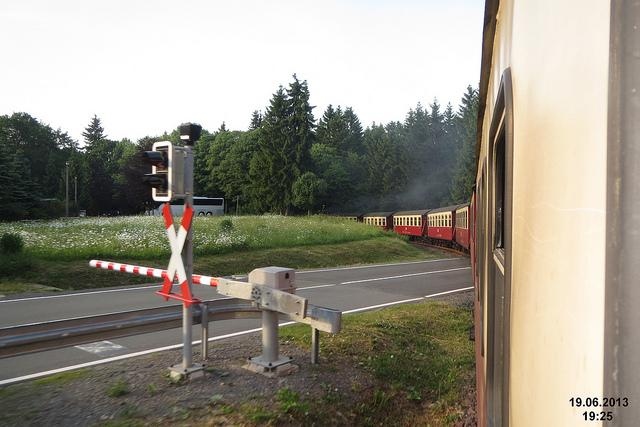What color is the area of the train car around the window? yellow 